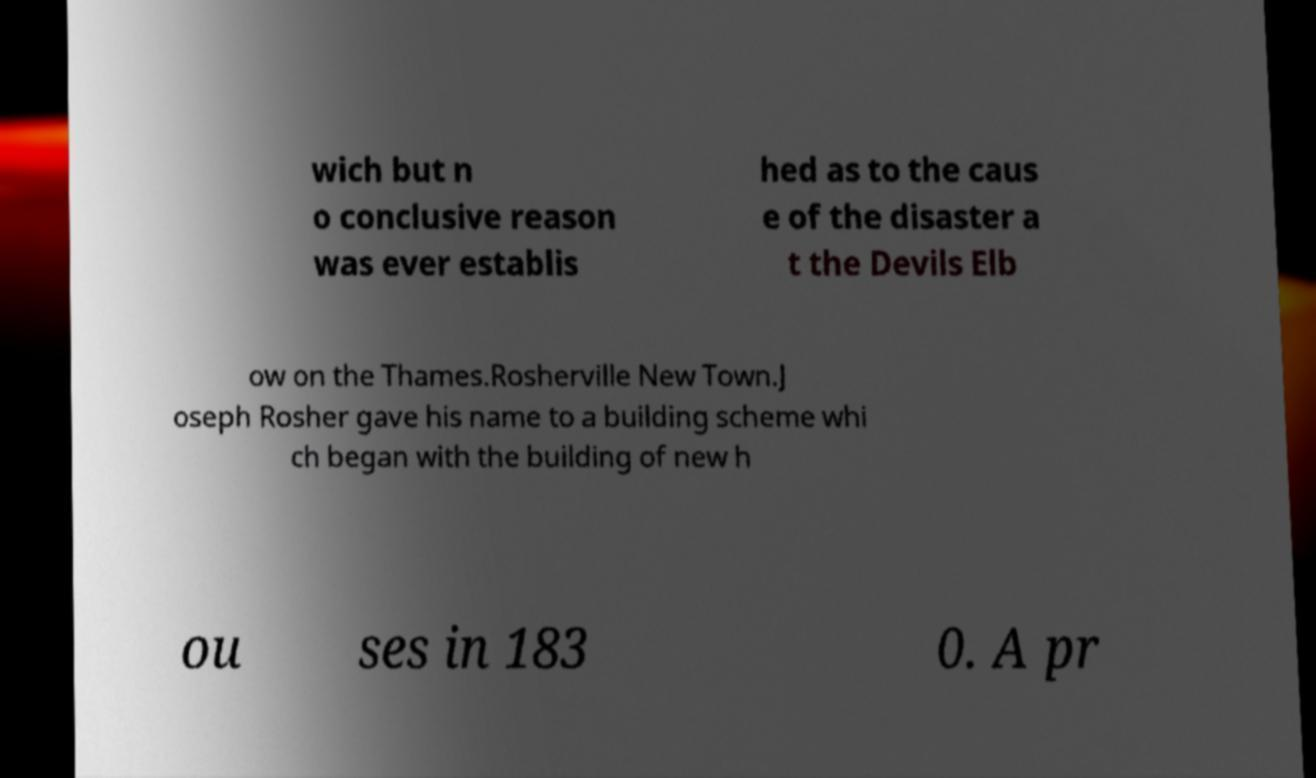What messages or text are displayed in this image? I need them in a readable, typed format. wich but n o conclusive reason was ever establis hed as to the caus e of the disaster a t the Devils Elb ow on the Thames.Rosherville New Town.J oseph Rosher gave his name to a building scheme whi ch began with the building of new h ou ses in 183 0. A pr 